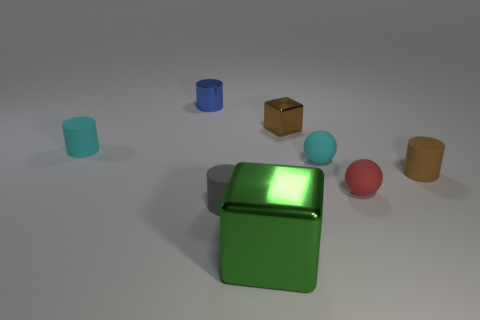There is a big metallic thing; is it the same shape as the small rubber thing that is left of the gray matte object?
Provide a short and direct response. No. The block that is in front of the cyan thing that is on the right side of the block that is behind the big block is made of what material?
Give a very brief answer. Metal. Is there a cylinder of the same size as the red matte thing?
Your answer should be very brief. Yes. There is a gray cylinder that is made of the same material as the brown cylinder; what is its size?
Offer a very short reply. Small. The small brown metallic object is what shape?
Ensure brevity in your answer.  Cube. Does the small red thing have the same material as the cyan thing in front of the tiny cyan cylinder?
Give a very brief answer. Yes. How many things are tiny blue spheres or tiny blue things?
Keep it short and to the point. 1. Is there a small cyan metal object?
Give a very brief answer. No. There is a rubber object right of the tiny ball in front of the brown matte cylinder; what shape is it?
Make the answer very short. Cylinder. How many things are either shiny things that are left of the tiny gray cylinder or objects on the right side of the tiny cyan sphere?
Your answer should be very brief. 3. 